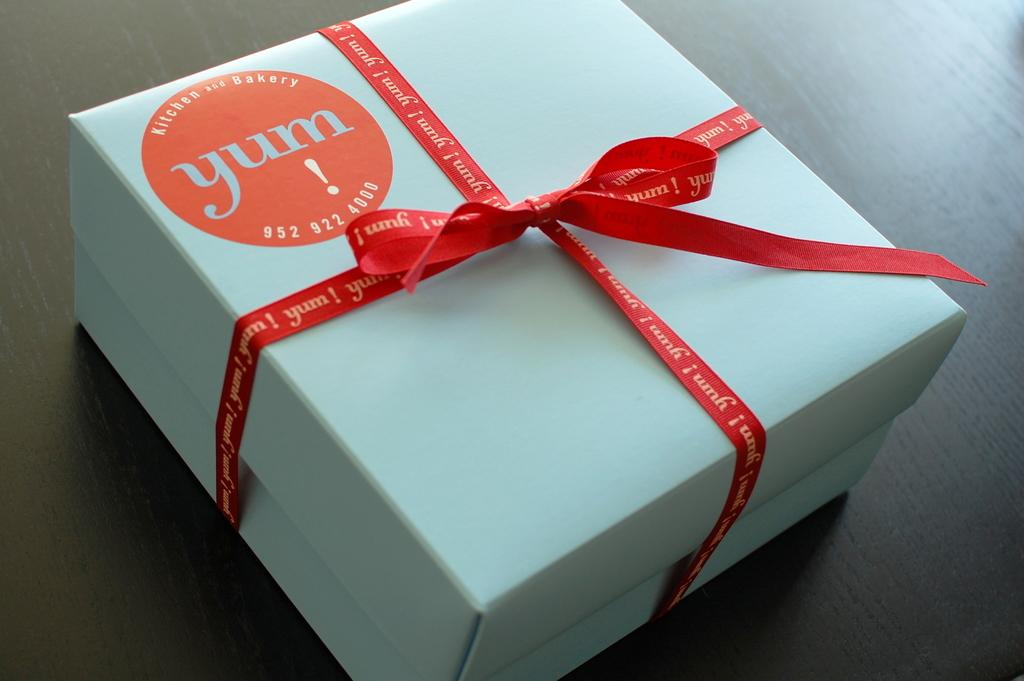Provide a one-sentence caption for the provided image. White box with an orange bow from "yum!". 